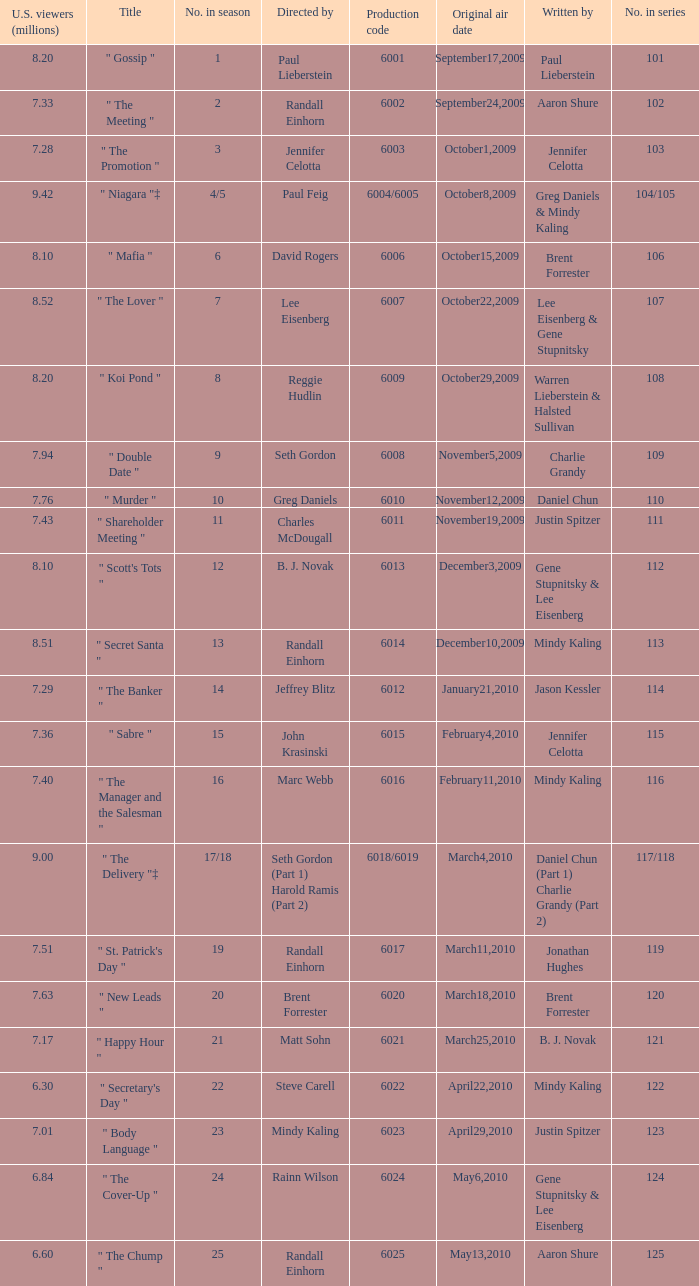Name the production code for number in season being 21 6021.0. 